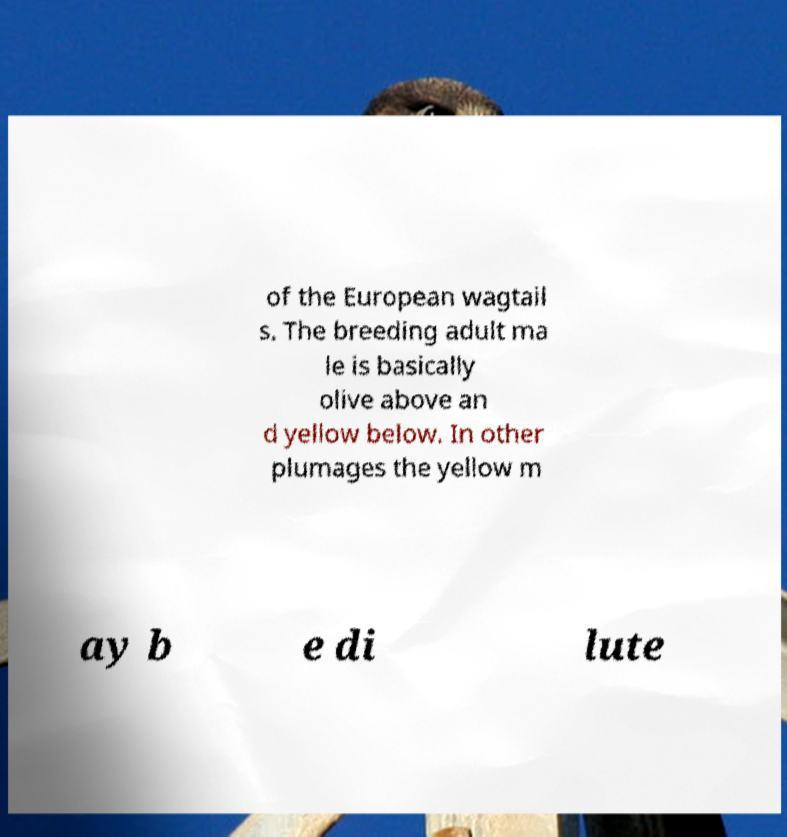Please read and relay the text visible in this image. What does it say? of the European wagtail s. The breeding adult ma le is basically olive above an d yellow below. In other plumages the yellow m ay b e di lute 